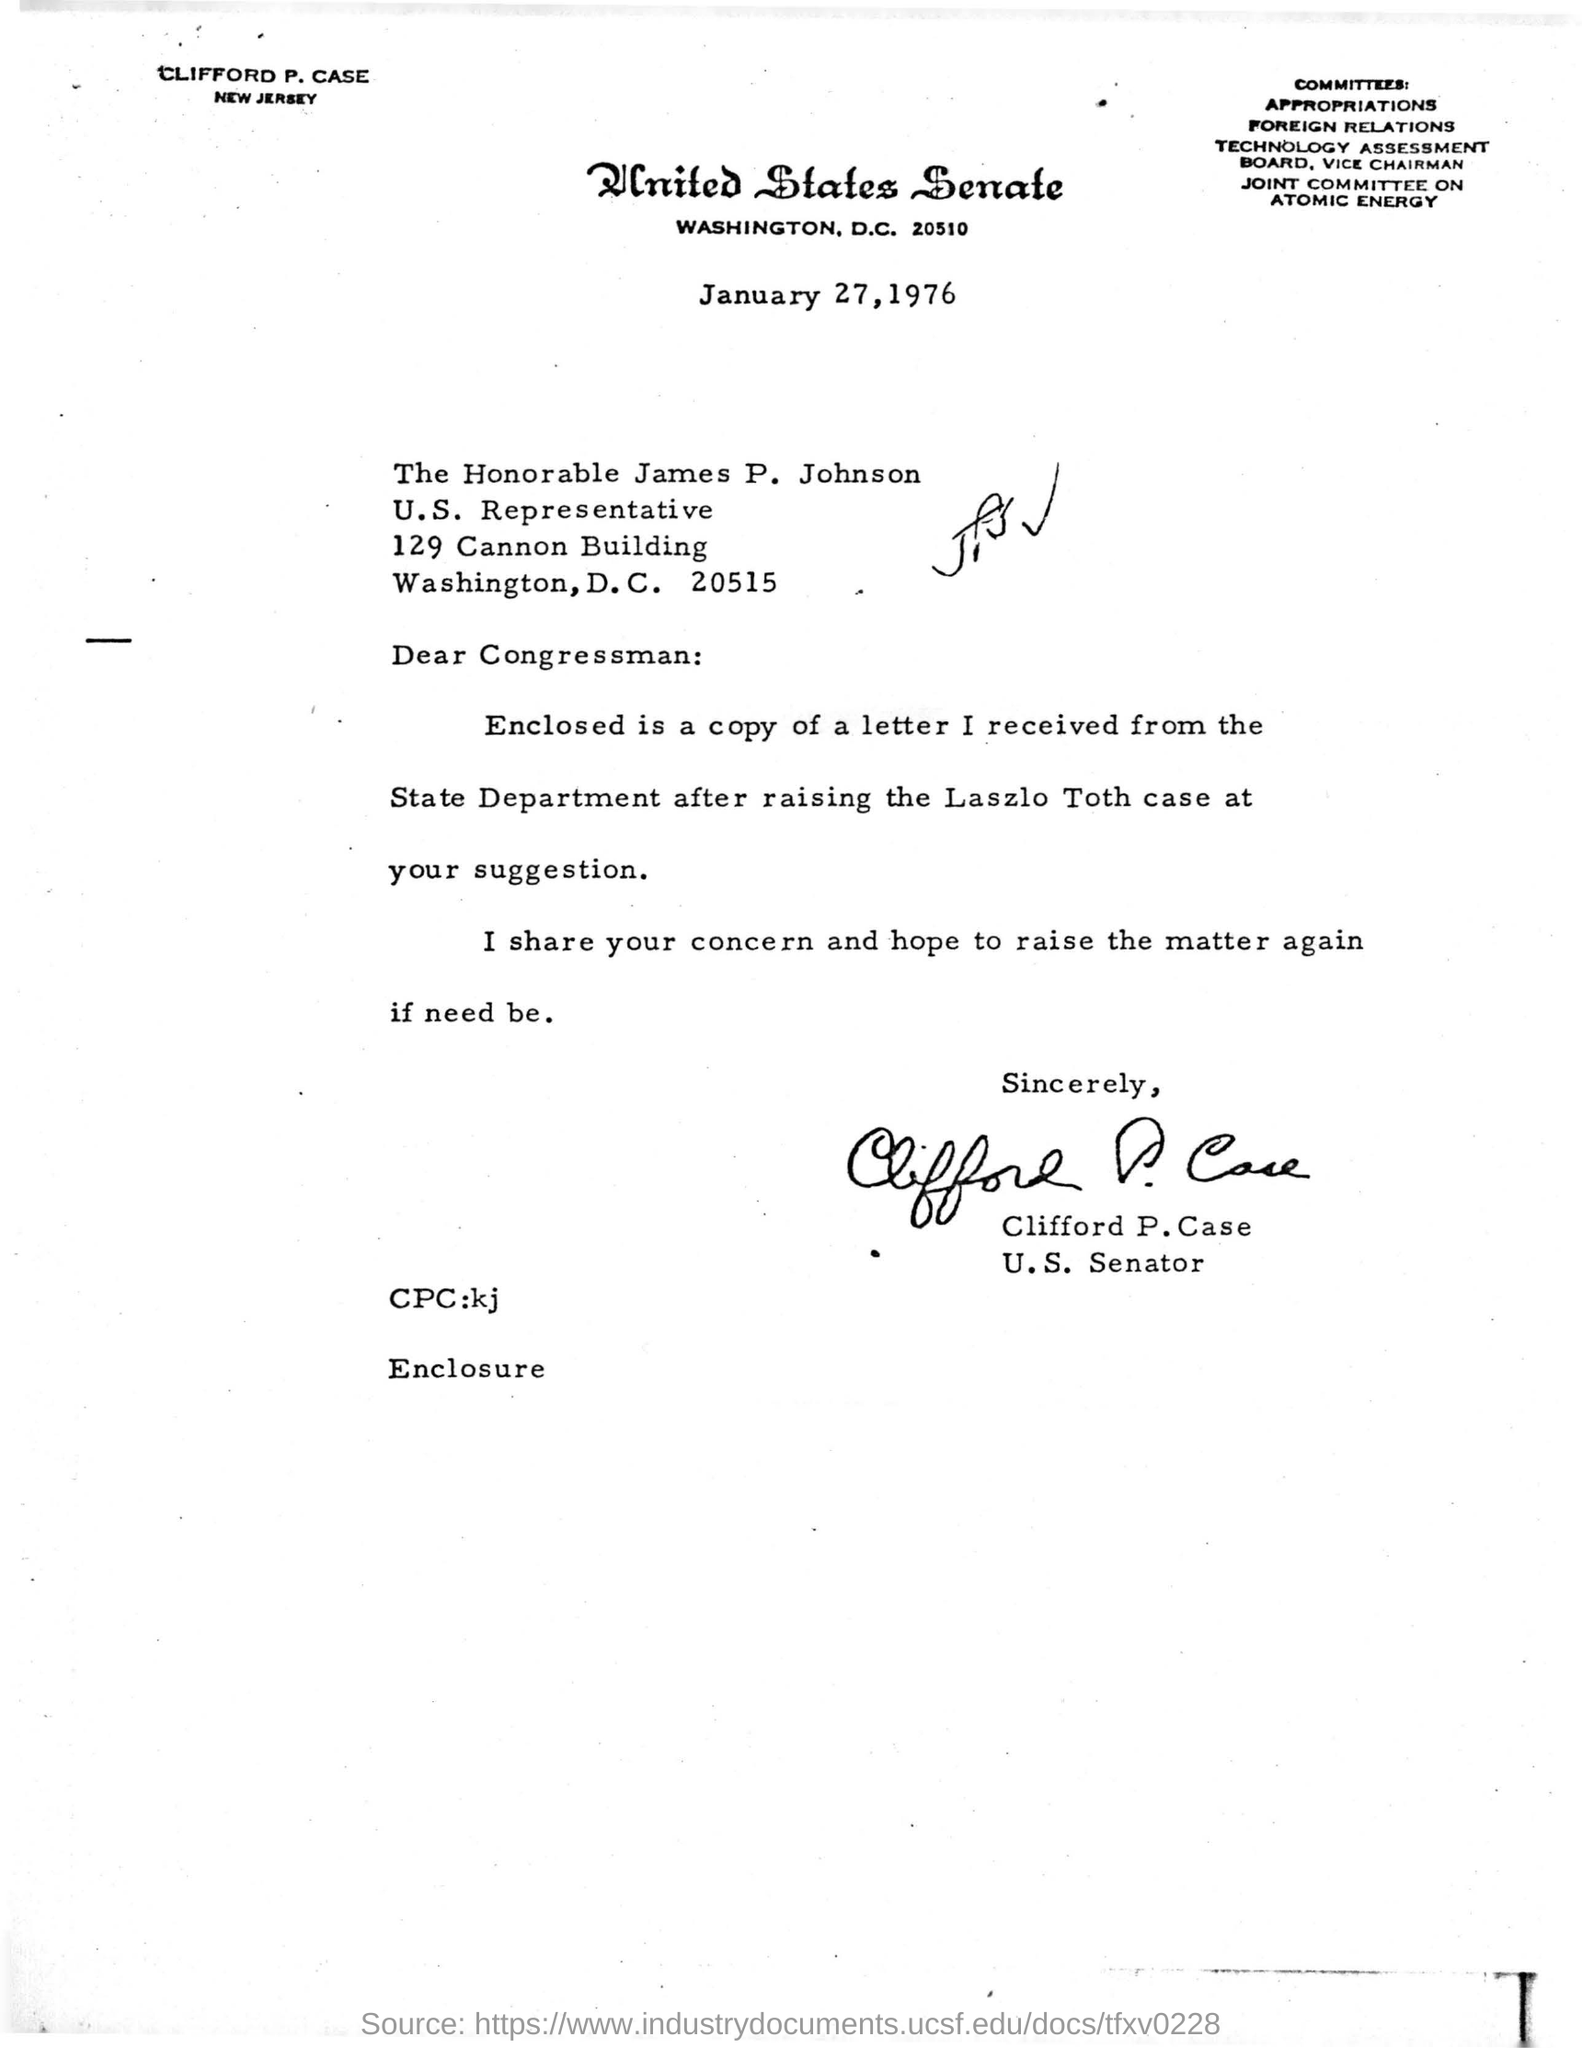List a handful of essential elements in this visual. James P. Johnson is a representative of the United States. The location of the United States Senate is Washington. On the date of January 27, 1976, this letter was written. Clifford P. Case has signed the letter. 